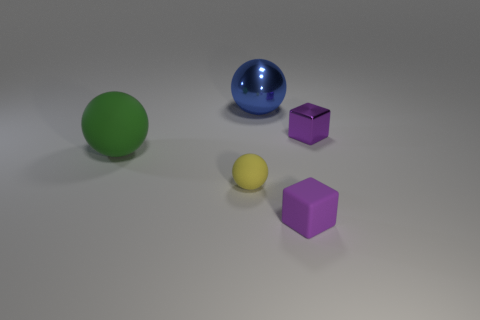Subtract 1 spheres. How many spheres are left? 2 Add 3 cyan balls. How many objects exist? 8 Subtract all spheres. How many objects are left? 2 Add 4 cyan metal cylinders. How many cyan metal cylinders exist? 4 Subtract 1 blue balls. How many objects are left? 4 Subtract all tiny metal blocks. Subtract all large blue objects. How many objects are left? 3 Add 2 tiny yellow objects. How many tiny yellow objects are left? 3 